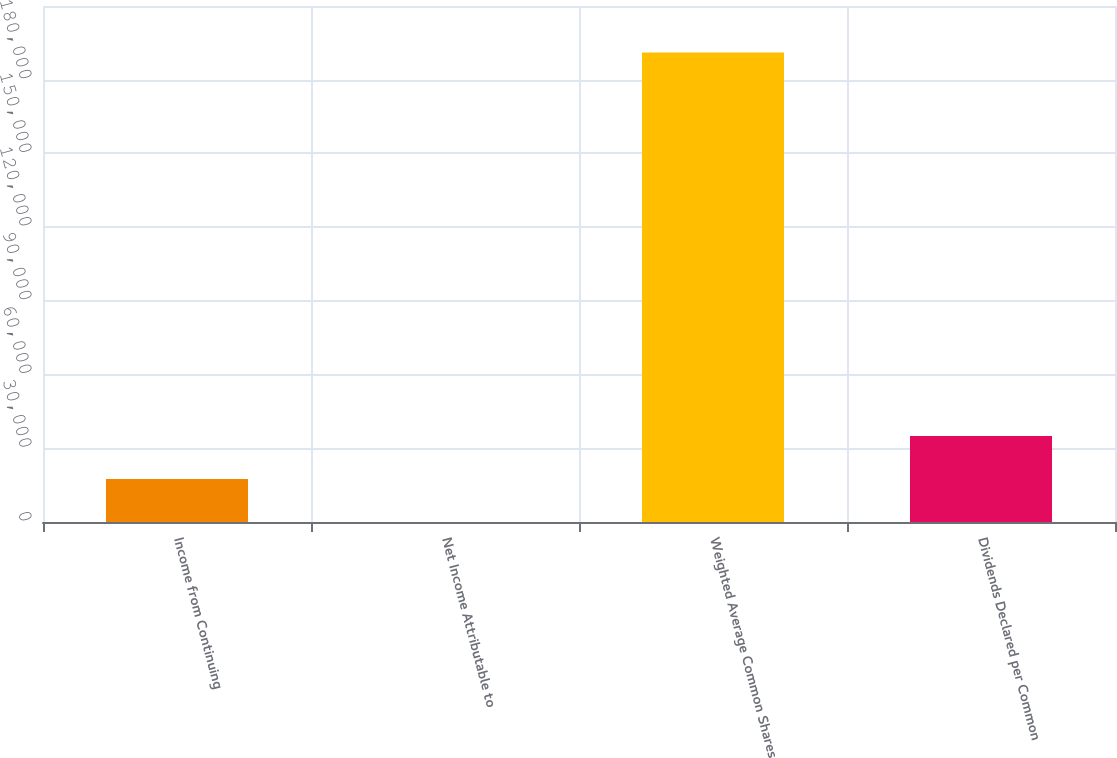<chart> <loc_0><loc_0><loc_500><loc_500><bar_chart><fcel>Income from Continuing<fcel>Net Income Attributable to<fcel>Weighted Average Common Shares<fcel>Dividends Declared per Common<nl><fcel>17487.6<fcel>0.98<fcel>191091<fcel>34974.2<nl></chart> 